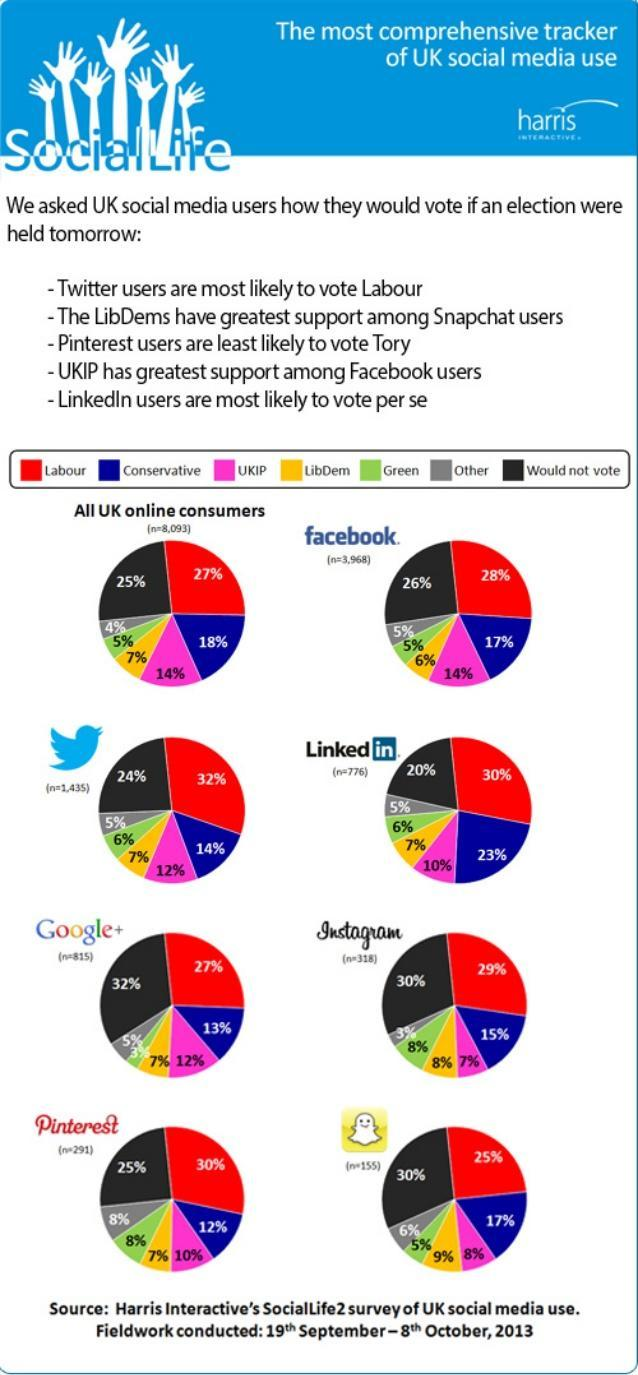What percentage of Facebook users does not support conservative or labour?
Answer the question with a short phrase. 69% What is the difference in percentage of conservative and UKIP among all UK online consumers? 4% What percentage of google users does not support conservative or UKIP? 75 What is the total percentage of green and libDem combined among Instagram users? 16% What is the total percentage of conservative, UKIP and labour combined among pinterest consumers? 52% How many pie charts are given in this infographic? 8 Whose supporters dominate among all social media users - LibDem or Green? LibDem What percentage of all UK social media users would like to vote? 75 What percentage of LinkedIn users does not support conservative or labour? 47% In which platform the percentage of user who would not like to vote is higher? google What is the total percentage of conservative and labour combined among all UK online consumers? 45 What percentage of Instagram users would like to vote? 70% Which social media platform give least support for labour? snapchat 